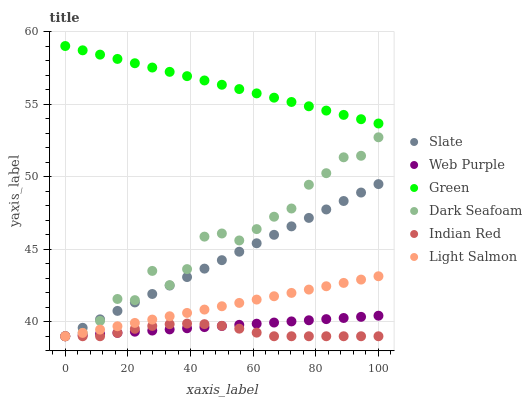Does Indian Red have the minimum area under the curve?
Answer yes or no. Yes. Does Green have the maximum area under the curve?
Answer yes or no. Yes. Does Slate have the minimum area under the curve?
Answer yes or no. No. Does Slate have the maximum area under the curve?
Answer yes or no. No. Is Slate the smoothest?
Answer yes or no. Yes. Is Dark Seafoam the roughest?
Answer yes or no. Yes. Is Dark Seafoam the smoothest?
Answer yes or no. No. Is Slate the roughest?
Answer yes or no. No. Does Light Salmon have the lowest value?
Answer yes or no. Yes. Does Green have the lowest value?
Answer yes or no. No. Does Green have the highest value?
Answer yes or no. Yes. Does Slate have the highest value?
Answer yes or no. No. Is Indian Red less than Green?
Answer yes or no. Yes. Is Green greater than Web Purple?
Answer yes or no. Yes. Does Light Salmon intersect Web Purple?
Answer yes or no. Yes. Is Light Salmon less than Web Purple?
Answer yes or no. No. Is Light Salmon greater than Web Purple?
Answer yes or no. No. Does Indian Red intersect Green?
Answer yes or no. No. 